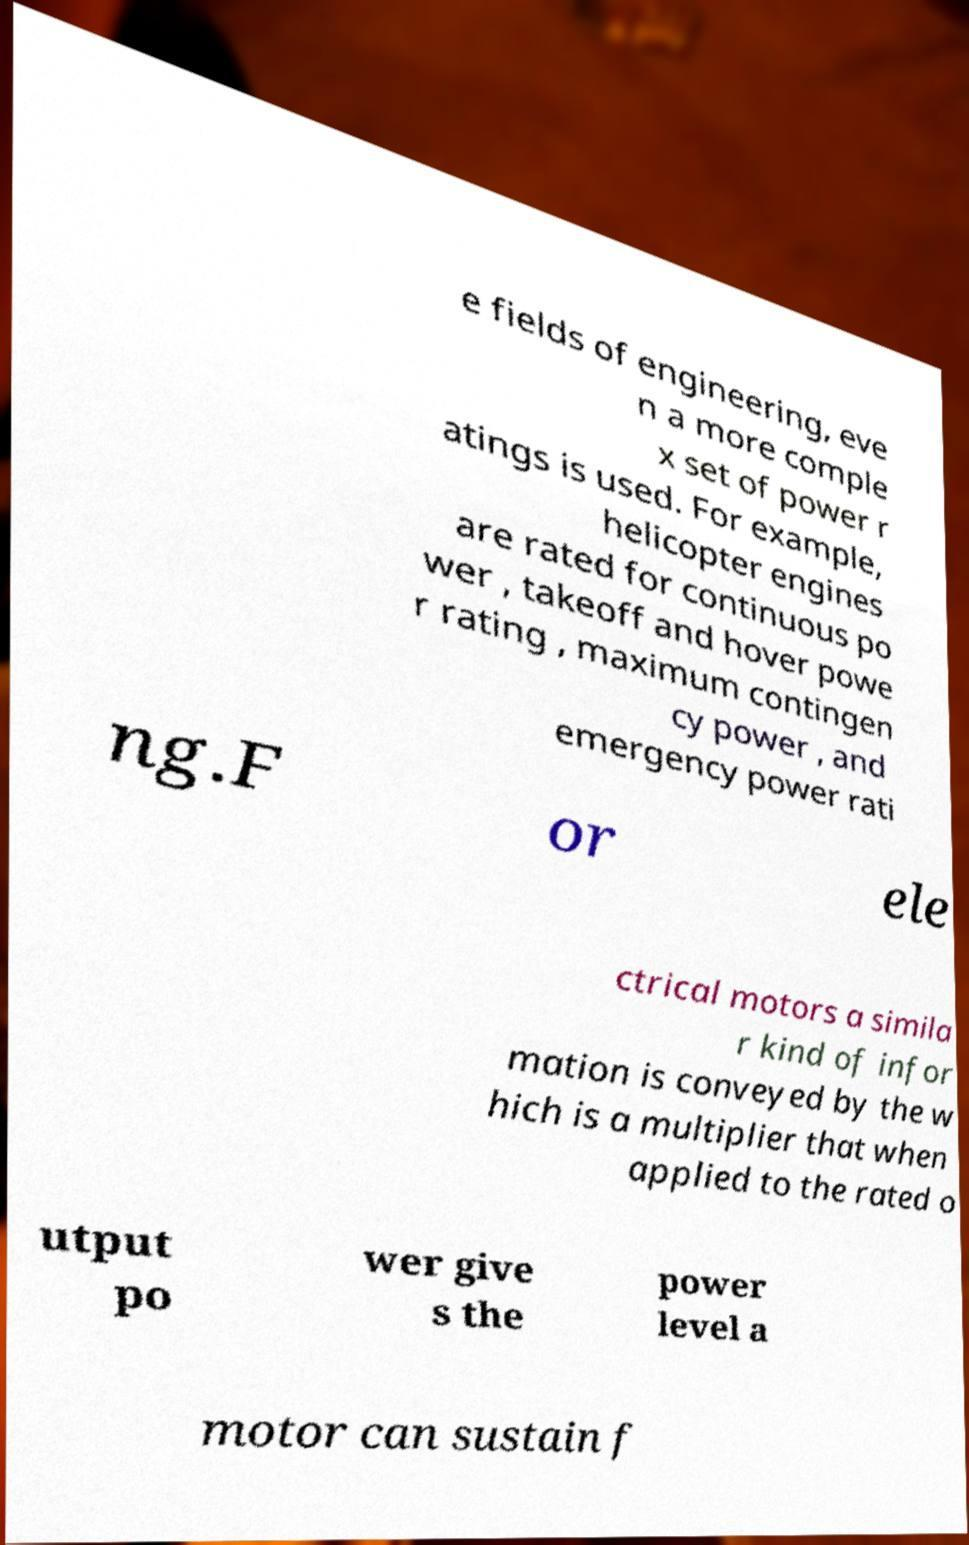There's text embedded in this image that I need extracted. Can you transcribe it verbatim? e fields of engineering, eve n a more comple x set of power r atings is used. For example, helicopter engines are rated for continuous po wer , takeoff and hover powe r rating , maximum contingen cy power , and emergency power rati ng.F or ele ctrical motors a simila r kind of infor mation is conveyed by the w hich is a multiplier that when applied to the rated o utput po wer give s the power level a motor can sustain f 